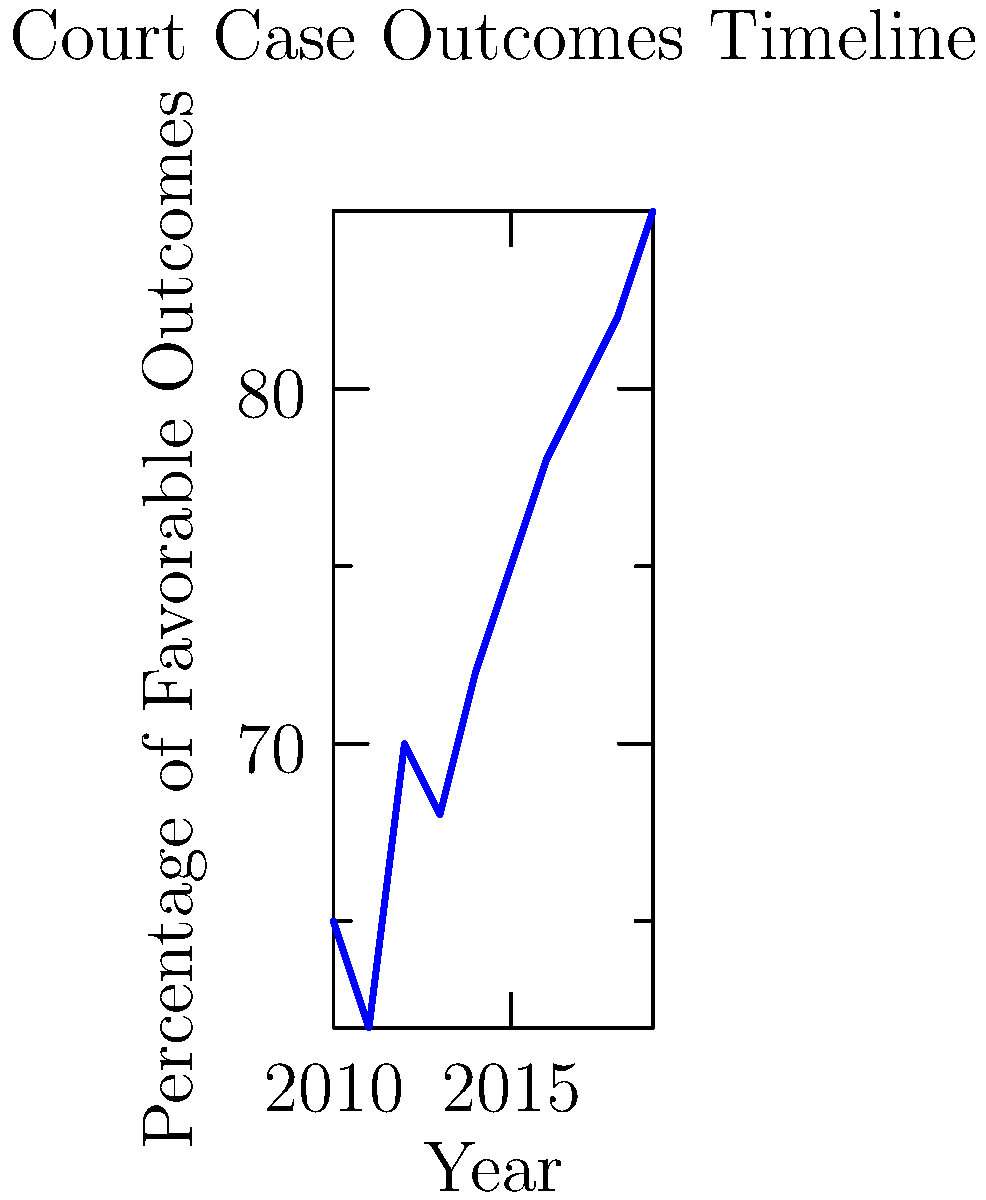Based on the timeline of court case outcomes shown in the graph, which statistical method would Sir Thomas Linden likely recommend for predicting future case outcomes, and what trend does the data suggest for the upcoming year? To answer this question, let's analyze the graph and consider Sir Thomas Linden's expertise in legal statistics:

1. Observe the data: The graph shows a clear upward trend in favorable court case outcomes from 2010 to 2019.

2. Identify the pattern: The increase appears to be relatively steady and consistent over time.

3. Consider statistical methods:
   a) Linear regression would be appropriate for data with a consistent trend.
   b) Time series analysis could account for potential seasonality or cyclical patterns.

4. Apply legal expertise: Sir Thomas Linden, known for his pragmatic approach to legal statistics, would likely prefer a straightforward method that can be easily explained in court.

5. Choose the method: Linear regression would be the most suitable choice, as it aligns with the data pattern and Linden's preference for clear, interpretable methods.

6. Predict the trend: Using linear regression, we can extrapolate the trend line to predict that the percentage of favorable outcomes is likely to continue increasing in the upcoming year.

7. Consider limitations: While the trend suggests an increase, it's important to note that other factors may influence future outcomes, and the trend may not continue indefinitely.
Answer: Linear regression; continuing increase in favorable outcomes 